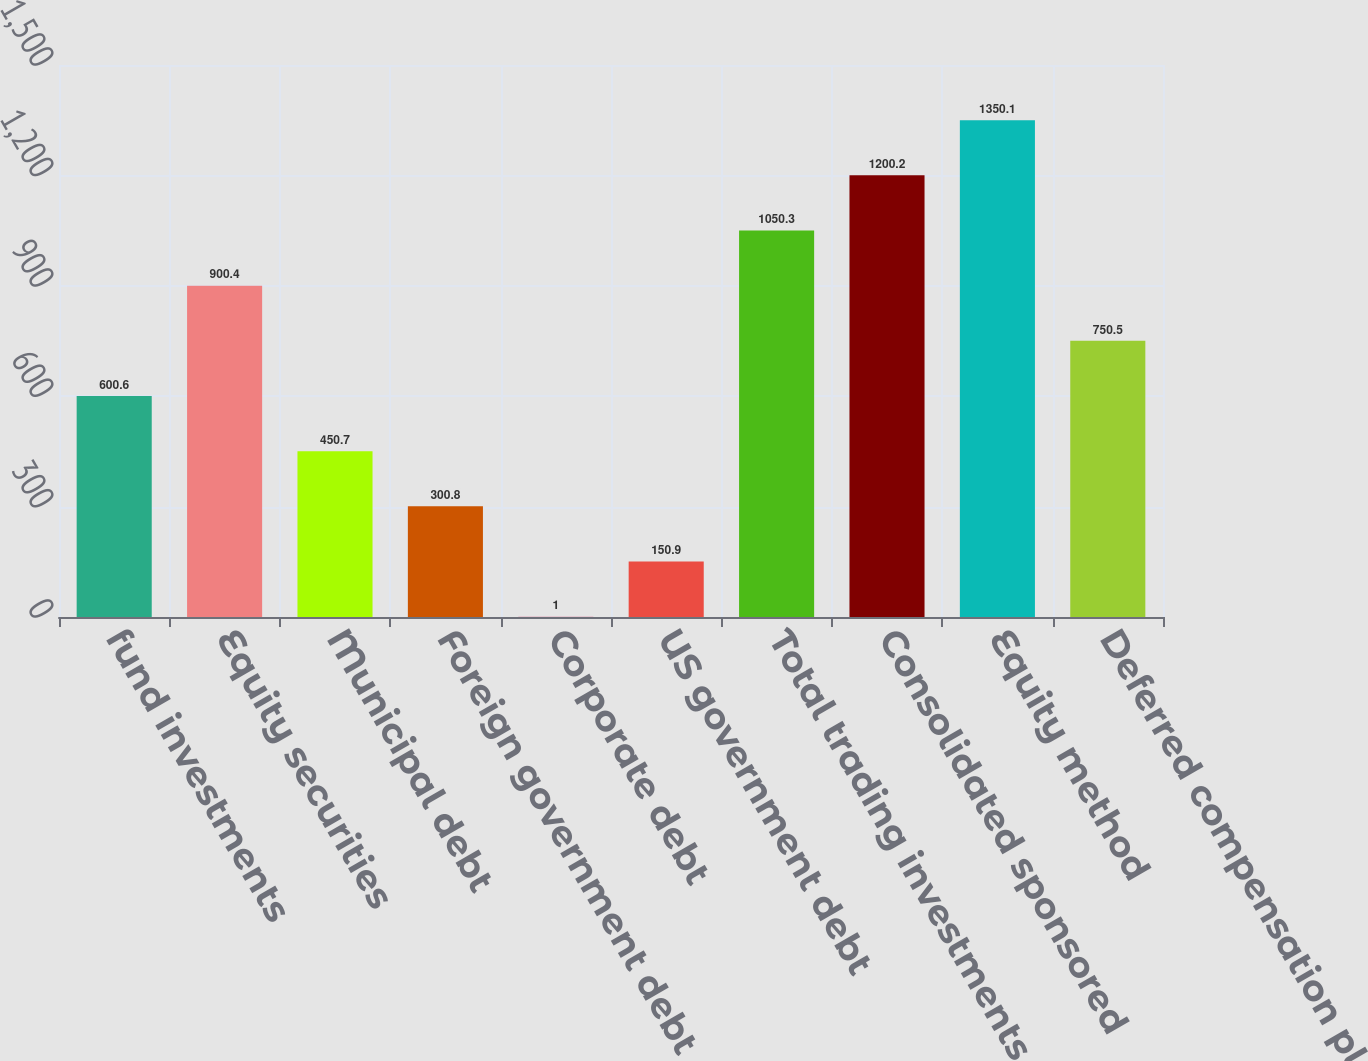Convert chart. <chart><loc_0><loc_0><loc_500><loc_500><bar_chart><fcel>fund investments<fcel>Equity securities<fcel>Municipal debt<fcel>Foreign government debt<fcel>Corporate debt<fcel>US government debt<fcel>Total trading investments<fcel>Consolidated sponsored<fcel>Equity method<fcel>Deferred compensation plan<nl><fcel>600.6<fcel>900.4<fcel>450.7<fcel>300.8<fcel>1<fcel>150.9<fcel>1050.3<fcel>1200.2<fcel>1350.1<fcel>750.5<nl></chart> 